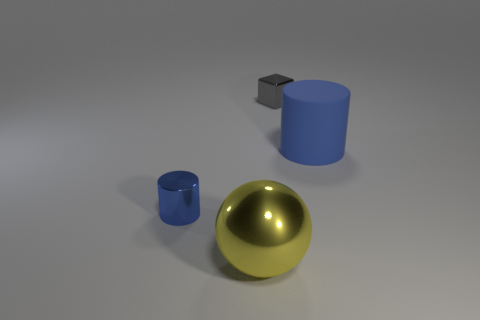If the scene were part of a computer graphics project, what techniques might have been used to create it? If this image is part of a computer graphics project, techniques such as 3D modeling to create the geometry of the objects, texture mapping for adding details and colors, and ray tracing or rasterization for realistic lighting and shadows would have likely been used. 